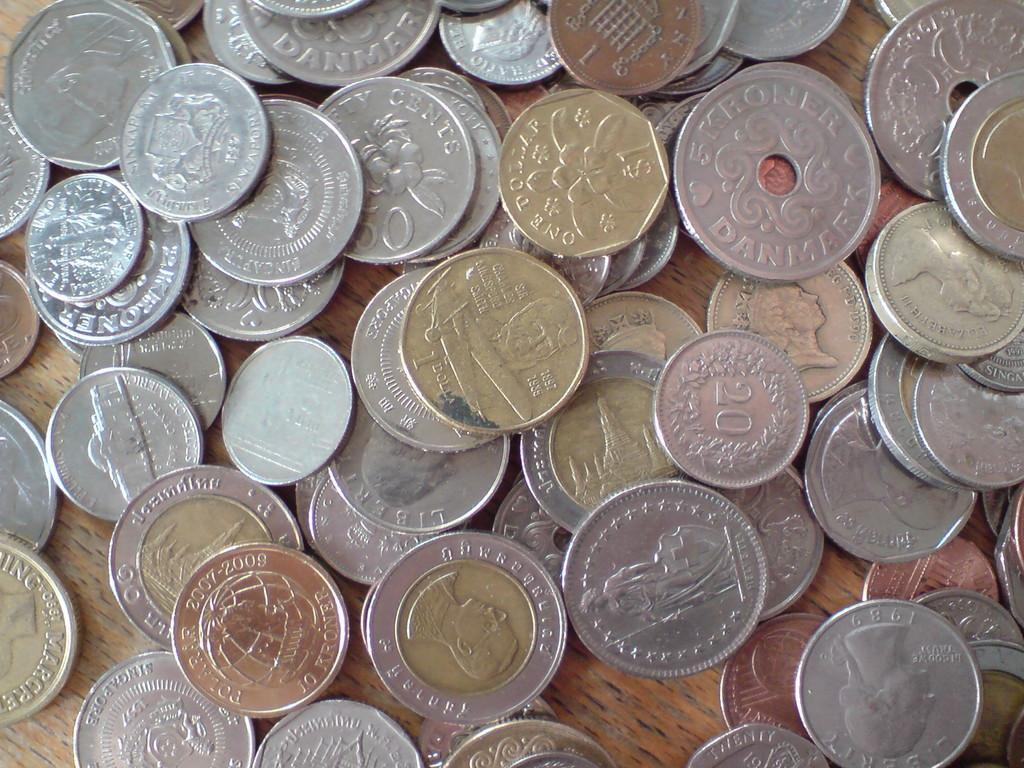Provide a one-sentence caption for the provided image. A collection of scattered coins contains American quarters and Danish Kroner, among other coins. 